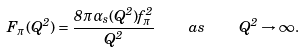Convert formula to latex. <formula><loc_0><loc_0><loc_500><loc_500>F _ { \pi } ( Q ^ { 2 } ) = \frac { 8 \pi \alpha _ { s } ( Q ^ { 2 } ) f _ { \pi } ^ { 2 } } { Q ^ { 2 } } \quad a s \quad Q ^ { 2 } \to \infty .</formula> 